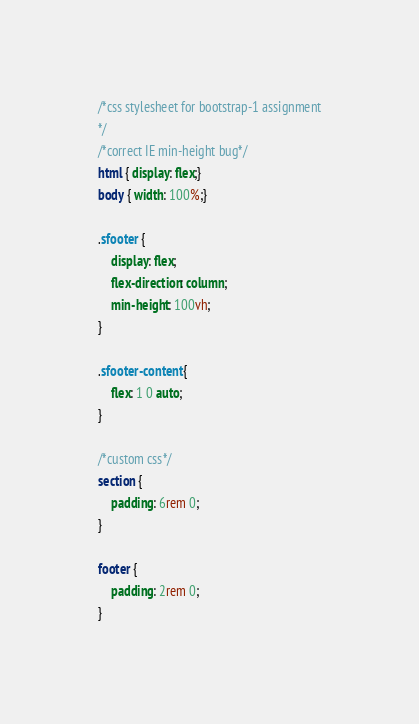Convert code to text. <code><loc_0><loc_0><loc_500><loc_500><_CSS_>/*css stylesheet for bootstrap-1 assignment
*/
/*correct IE min-height bug*/
html { display: flex;}
body { width: 100%;}

.sfooter {
	display: flex;
	flex-direction: column;
	min-height: 100vh;
}

.sfooter-content {
	flex: 1 0 auto;
}

/*custom css*/
section {
	padding: 6rem 0;
}

footer {
	padding: 2rem 0;
}</code> 